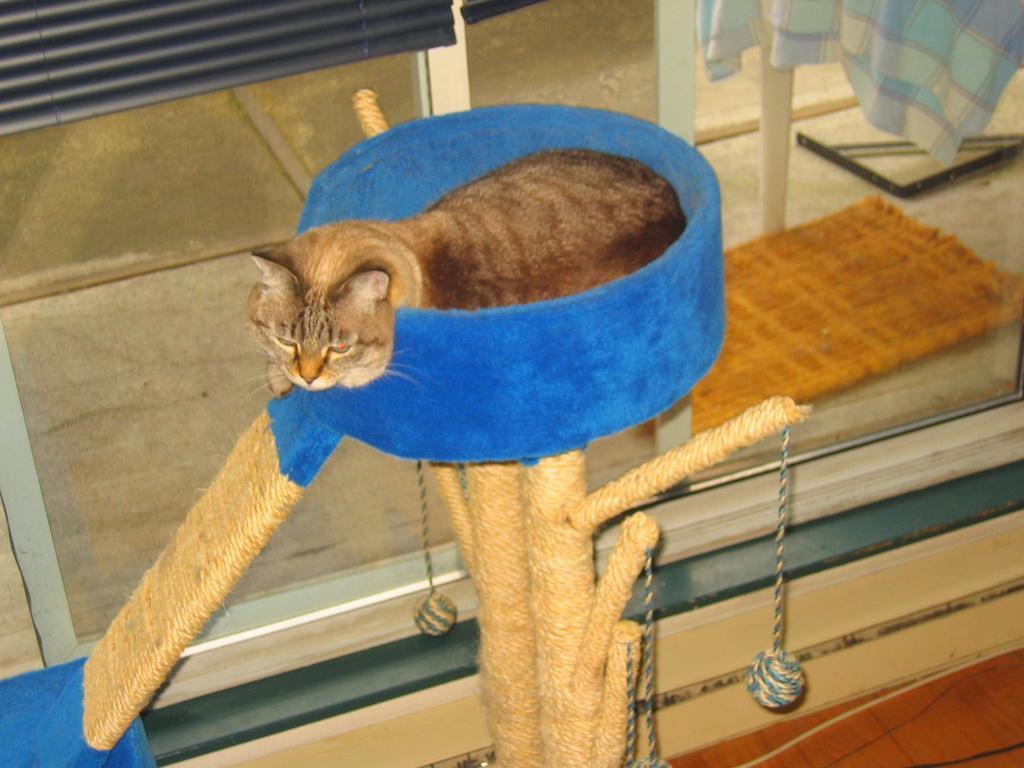Can you describe this image briefly? In the center of the image there is a cat. In the background of the image there is a glass door. At the bottom of the image there is wooden flooring. 